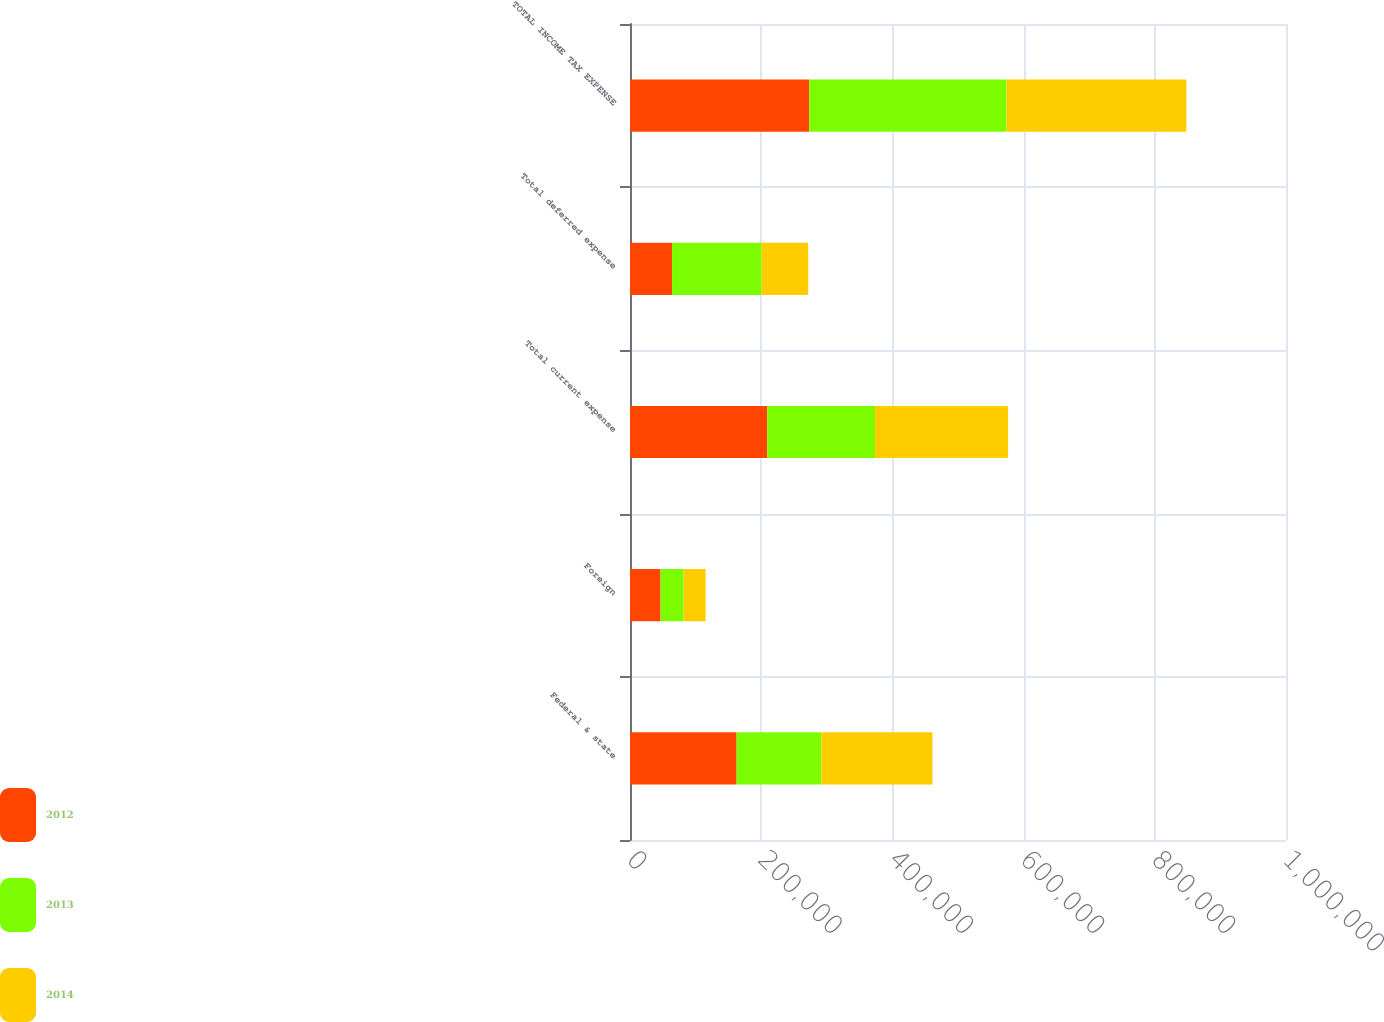Convert chart to OTSL. <chart><loc_0><loc_0><loc_500><loc_500><stacked_bar_chart><ecel><fcel>Federal & state<fcel>Foreign<fcel>Total current expense<fcel>Total deferred expense<fcel>TOTAL INCOME TAX EXPENSE<nl><fcel>2012<fcel>162483<fcel>46593<fcel>209076<fcel>64154<fcel>273230<nl><fcel>2013<fcel>129204<fcel>35188<fcel>164392<fcel>136400<fcel>300792<nl><fcel>2014<fcel>169394<fcel>33520<fcel>202914<fcel>71132<fcel>274046<nl></chart> 